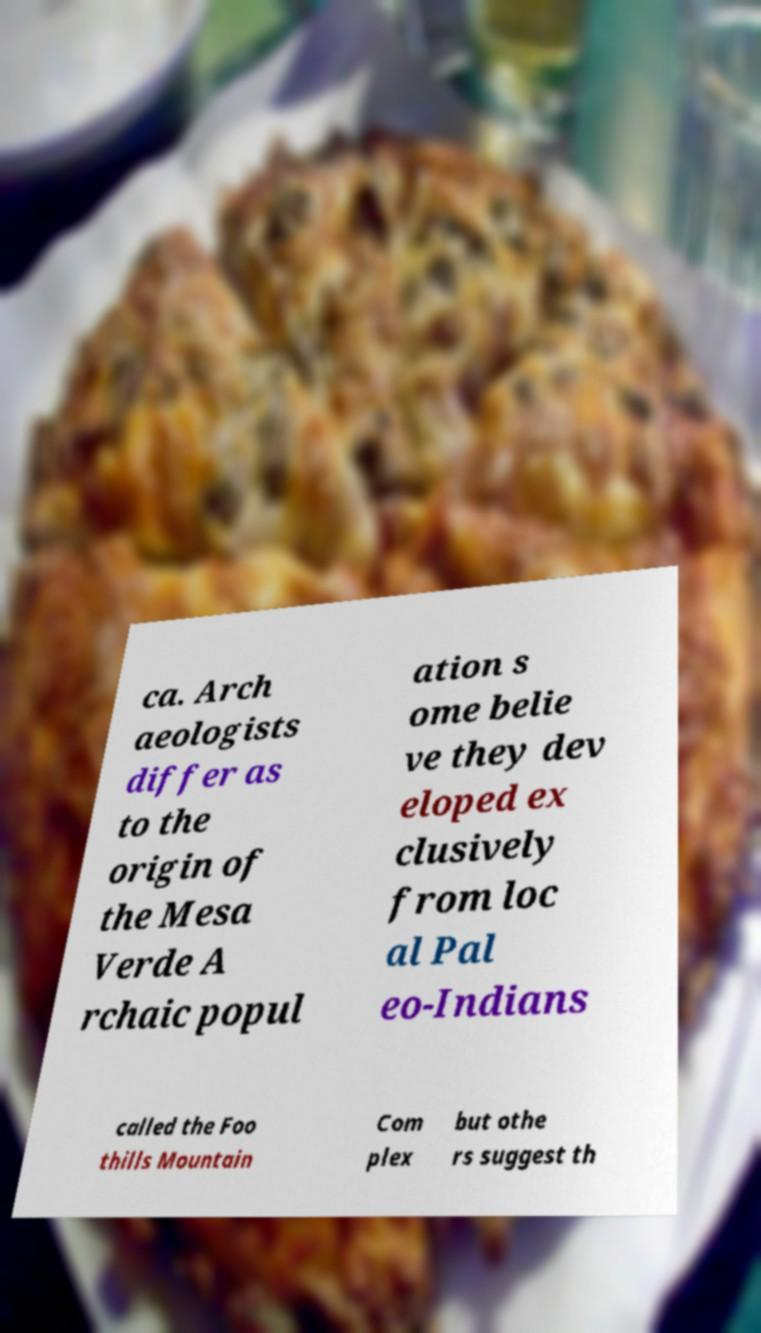Could you assist in decoding the text presented in this image and type it out clearly? ca. Arch aeologists differ as to the origin of the Mesa Verde A rchaic popul ation s ome belie ve they dev eloped ex clusively from loc al Pal eo-Indians called the Foo thills Mountain Com plex but othe rs suggest th 